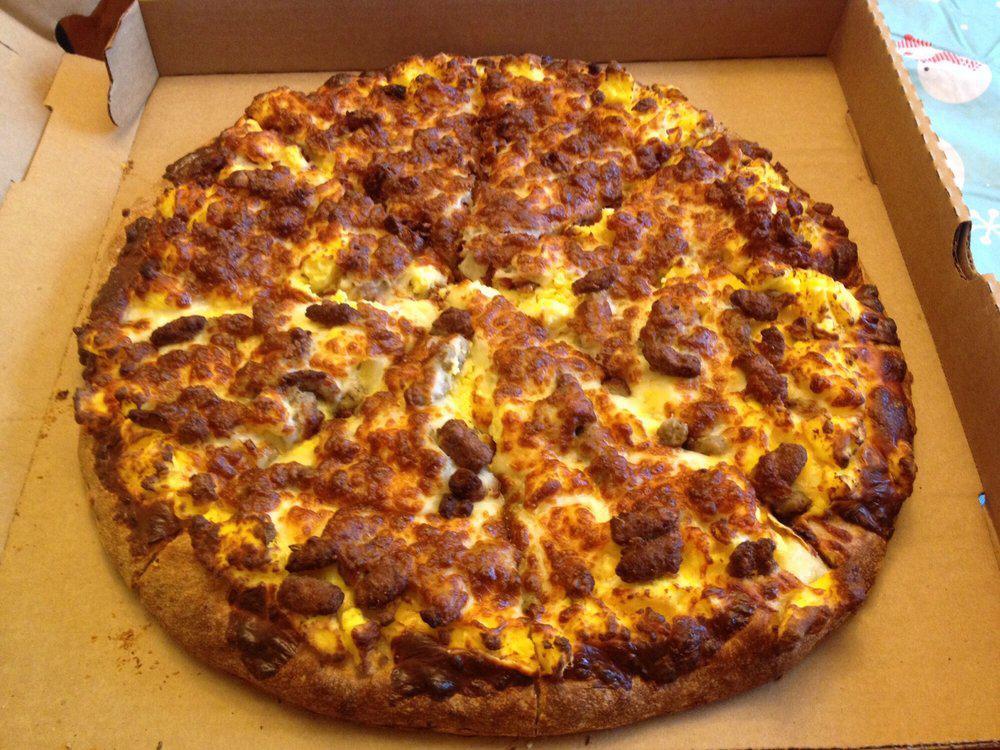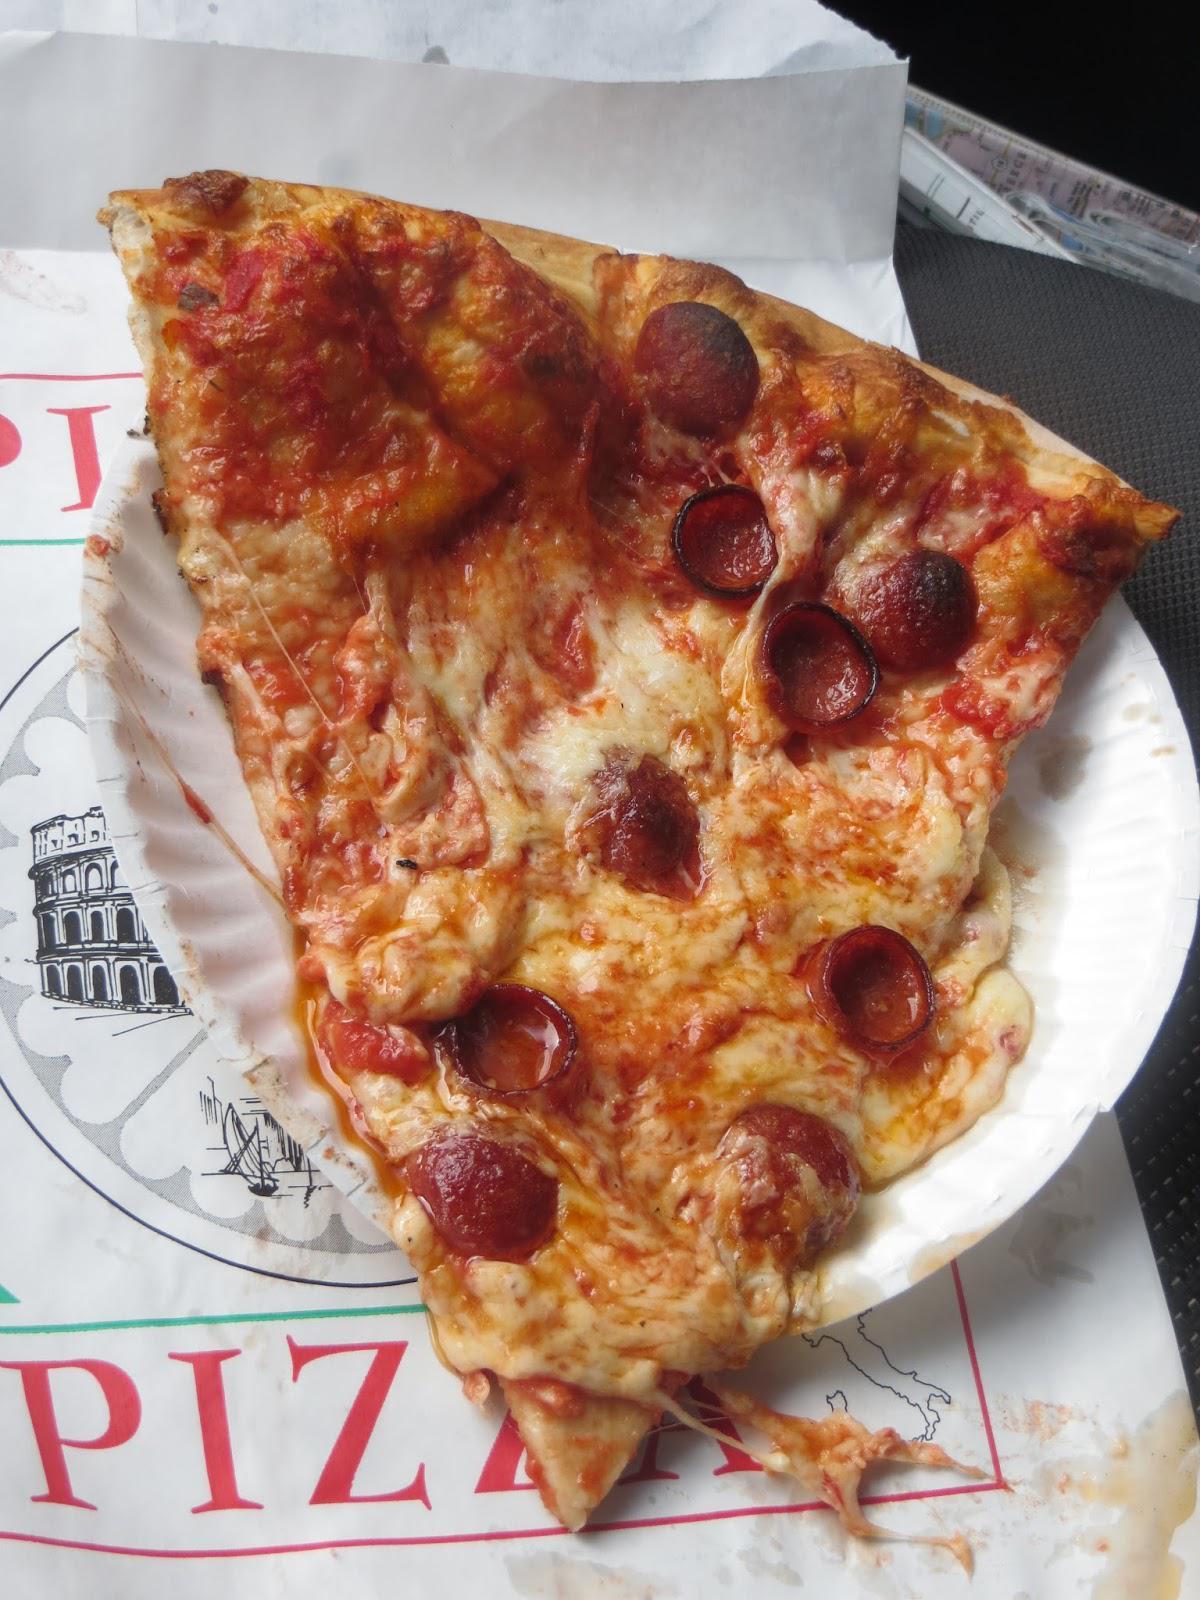The first image is the image on the left, the second image is the image on the right. Given the left and right images, does the statement "All the pizzas in these images are still whole circles and have not yet been cut into slices." hold true? Answer yes or no. No. 